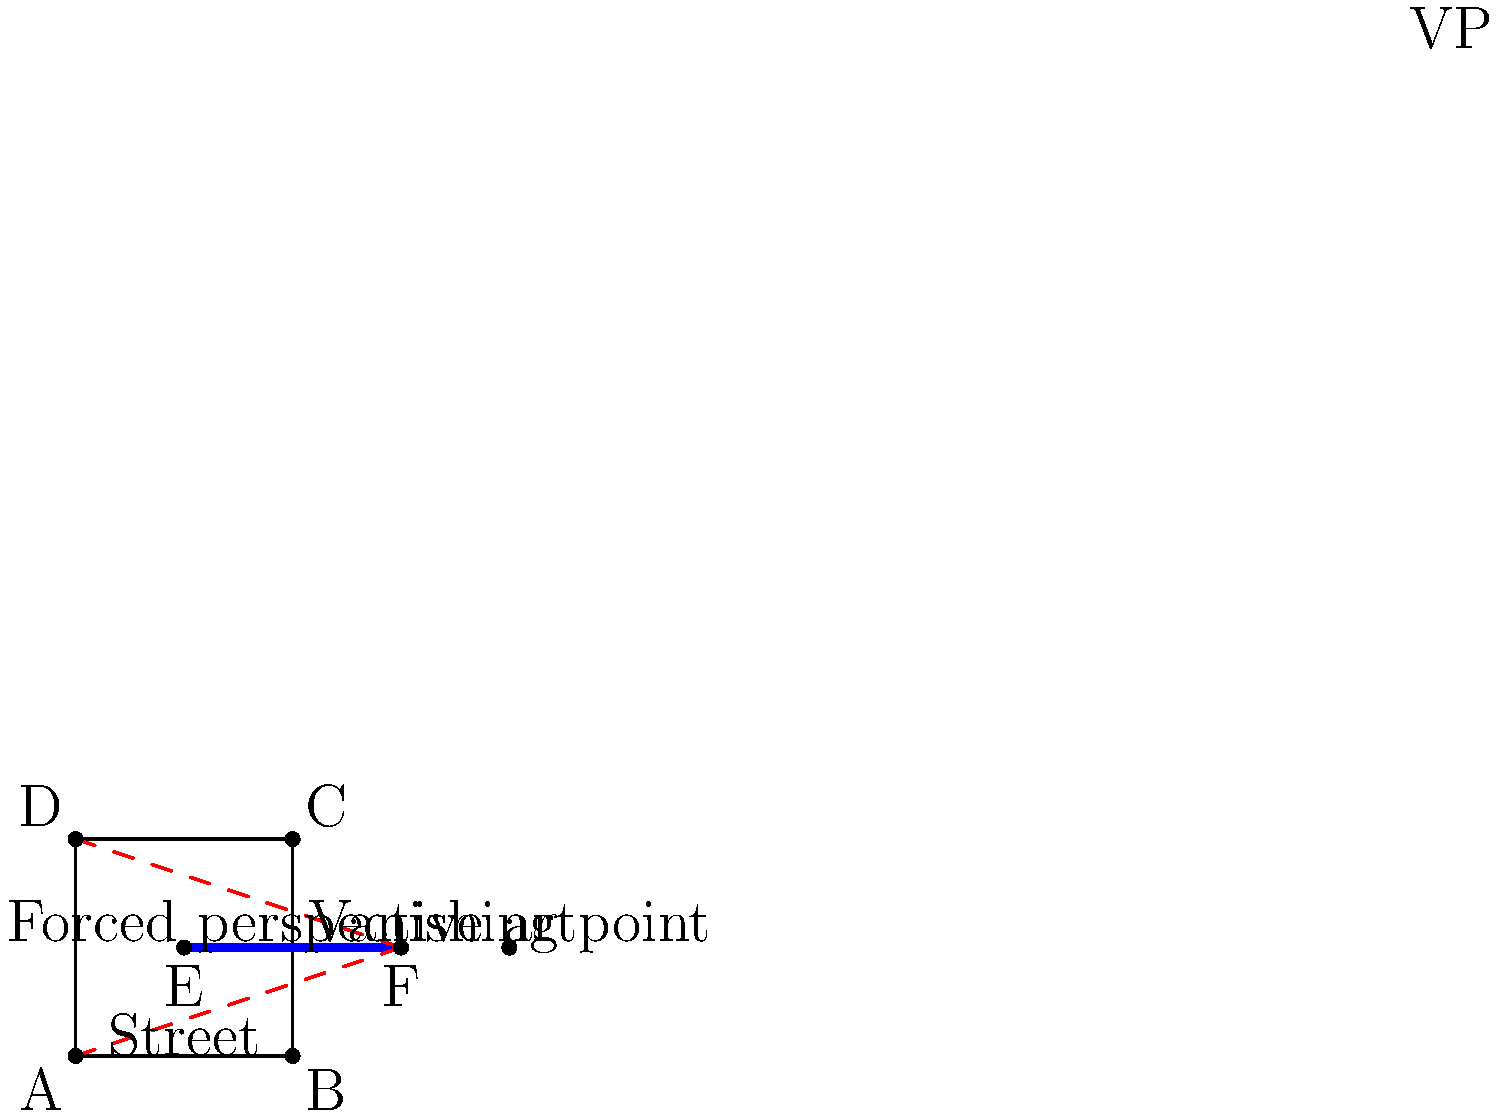In the context of Middle Eastern street art as a form of resistance, consider the forced perspective piece shown in the diagram. If the artist wants to create an illusion of depth using a single vanishing point, where should they position this point in relation to the street art piece to maximize the impact of the perspective? To determine the optimal position for the vanishing point in this forced perspective street art piece, we need to consider the following steps:

1. Understand forced perspective: Forced perspective is an optical illusion technique that manipulates human visual perception to make objects appear closer, farther, larger, or smaller than they actually are.

2. Identify the street art piece: In the diagram, the blue line segment EF represents the forced perspective street art piece.

3. Analyze the street layout: The rectangle ABCD represents the street where the art is created.

4. Determine the vanishing point: In a one-point perspective, all parallel lines that are perpendicular to the picture plane converge at a single vanishing point.

5. Extend the perspective lines: To find the optimal position for the vanishing point, we need to extend the edges of the street (AD and BC) until they intersect.

6. Locate the vanishing point: The intersection of these extended lines (beyond point F in the diagram) is where the vanishing point (VP) should be placed for maximum impact.

7. Consider the impact: Positioning the vanishing point further away from the art piece (beyond point F) will create a more dramatic sense of depth and distance, enhancing the illusion and the artwork's impact as a form of resistance.

Therefore, to maximize the impact of the perspective, the artist should position the vanishing point (VP) beyond the end of the street art piece (point F), along the central axis of the street.
Answer: Beyond the end of the street art piece, along the street's central axis 